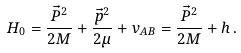Convert formula to latex. <formula><loc_0><loc_0><loc_500><loc_500>H _ { 0 } = \frac { \vec { P } ^ { 2 } } { 2 M } + \frac { \vec { p } ^ { 2 } } { 2 \mu } + v _ { A B } = \frac { \vec { P } ^ { 2 } } { 2 M } + h \, .</formula> 